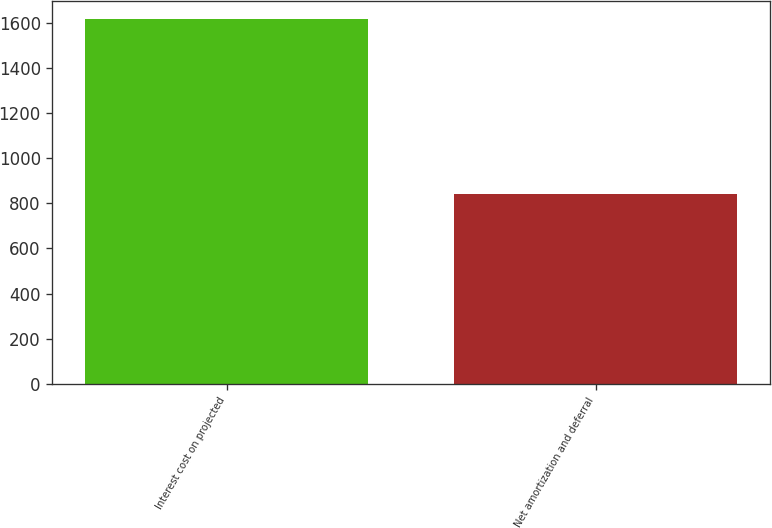Convert chart. <chart><loc_0><loc_0><loc_500><loc_500><bar_chart><fcel>Interest cost on projected<fcel>Net amortization and deferral<nl><fcel>1617<fcel>841<nl></chart> 